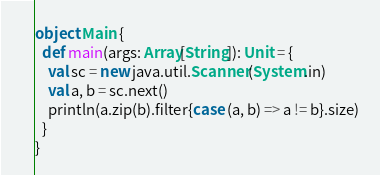Convert code to text. <code><loc_0><loc_0><loc_500><loc_500><_Scala_>object Main {
  def main(args: Array[String]): Unit = {
    val sc = new java.util.Scanner(System.in)
    val a, b = sc.next()
    println(a.zip(b).filter{case (a, b) => a != b}.size)
  }
}
</code> 